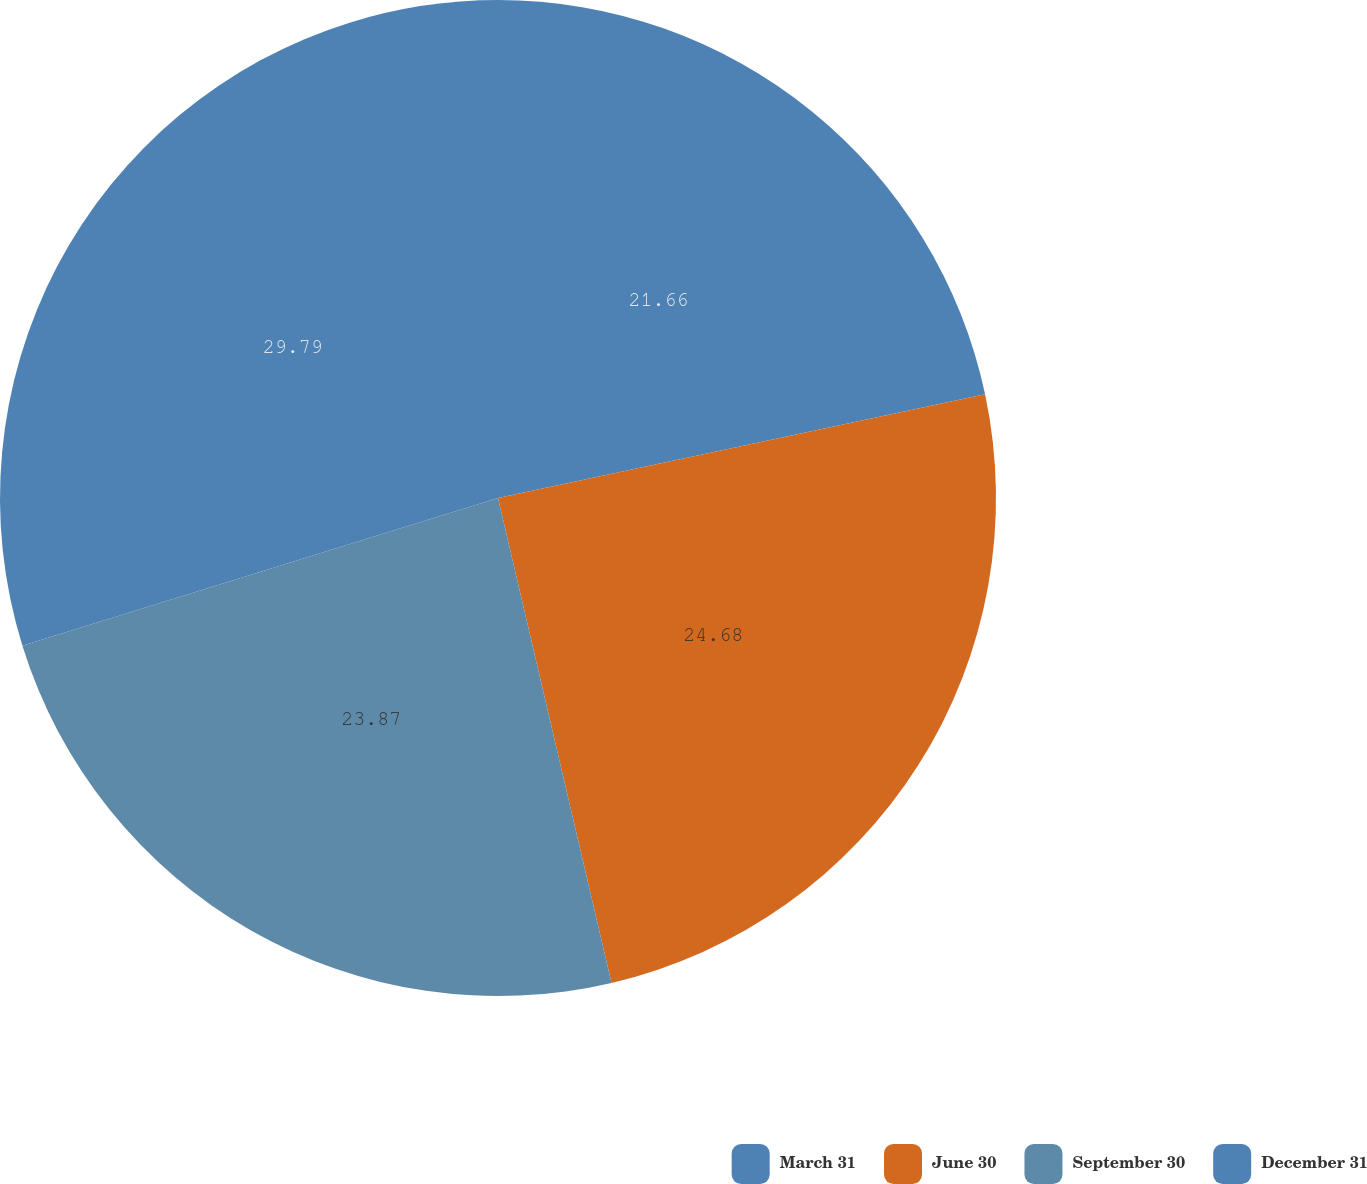Convert chart. <chart><loc_0><loc_0><loc_500><loc_500><pie_chart><fcel>March 31<fcel>June 30<fcel>September 30<fcel>December 31<nl><fcel>21.66%<fcel>24.68%<fcel>23.87%<fcel>29.79%<nl></chart> 